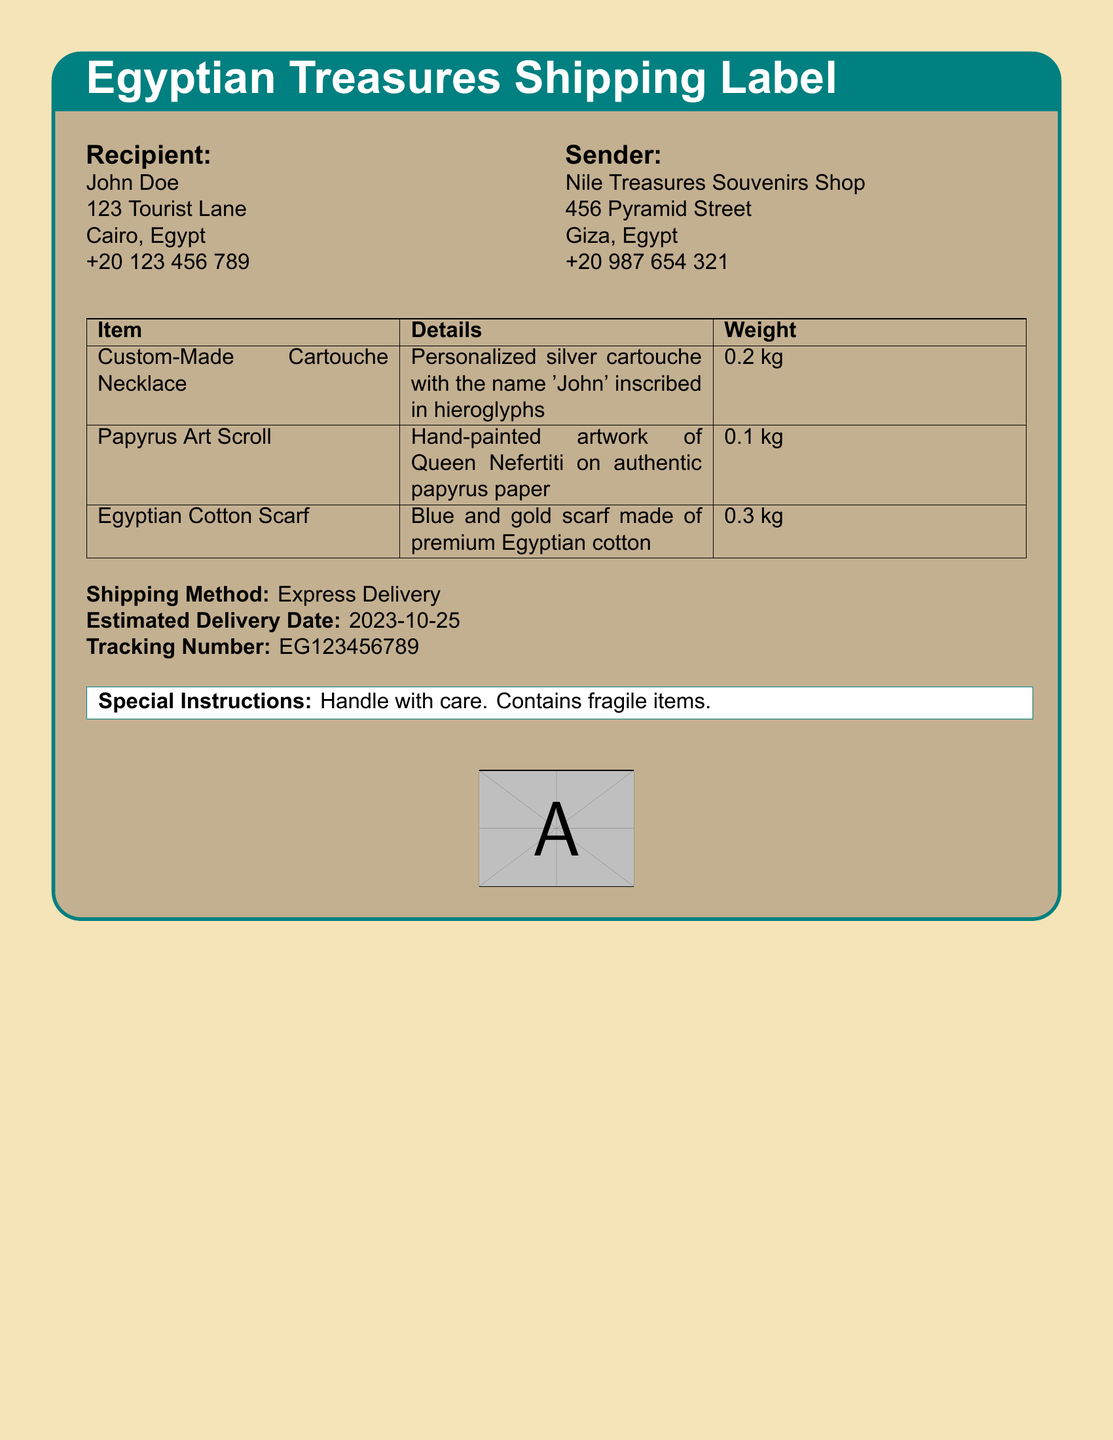What is the recipient's name? The recipient's name is clearly stated at the top of the shipping label under the Recipient section.
Answer: John Doe What is the shipping method used? The shipping method is mentioned towards the bottom of the shipping label, indicating how the items will be sent.
Answer: Express Delivery What is the estimated delivery date? The estimated delivery date is specified on the label and indicates when the package is expected to arrive.
Answer: 2023-10-25 What type of art is included in the shipment? The specific type of art included in the shipment is listed under the Item column of the shipping label.
Answer: Papyrus Art Scroll What is the weight of the Egyptian Cotton Scarf? The weight of the listed item can be found in the third column of the shipping details section.
Answer: 0.3 kg How many items are included in the shipment? The total number of items can be determined by counting the rows in the item's table on the shipping label.
Answer: 3 What special instructions are given for handling the package? The special instructions are provided at the bottom of the shipping label, which includes handling guidance.
Answer: Handle with care What does the cartouche necklace feature? The details regarding the necklace can be found in the description next to the item in the shipping label.
Answer: Personalized silver cartouche with the name 'John' inscribed in hieroglyphs 